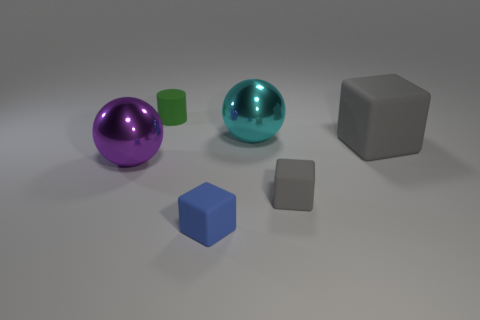Add 3 green rubber objects. How many objects exist? 9 Subtract all cylinders. How many objects are left? 5 Subtract 0 blue balls. How many objects are left? 6 Subtract all gray objects. Subtract all big rubber spheres. How many objects are left? 4 Add 5 small cylinders. How many small cylinders are left? 6 Add 4 tiny gray matte blocks. How many tiny gray matte blocks exist? 5 